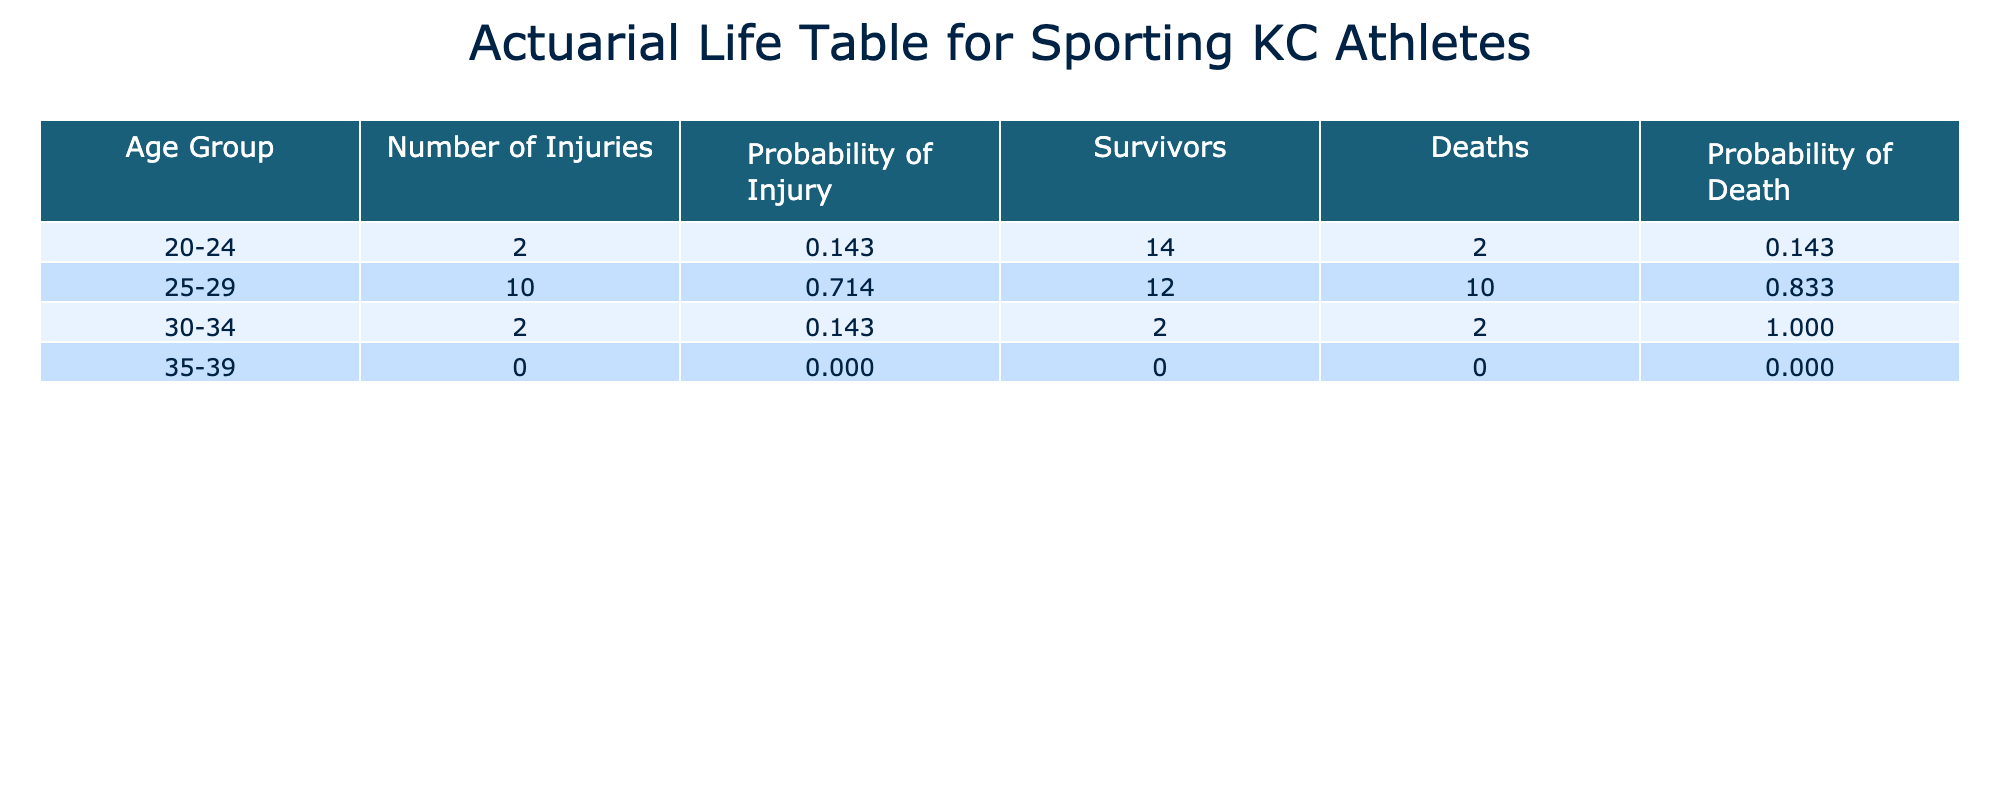What is the age group with the highest number of injuries? Looking at the "Number of Injuries" column, we see the counts for each age group. The age group "25-29" has 4 injuries, which is the highest compared to the others.
Answer: 25-29 How many athletes suffered hamstring tears? By examining the "Injury Type" column and counting the instances of "Hamstring Tear," we find that there is only one instance listed for Graham Zusi.
Answer: 1 What is the average age at injury for athletes in the "Midfielder" position? To find the average, we gather the ages of midfielders: Zusi (29), Espinoza (28), Sanchez (27), Hernandez (23), and Lobato (26). Their sum is 29 + 28 + 27 + 23 + 26 = 133, and dividing by the number of midfielders (5) gives us an average of 133/5 = 26.6.
Answer: 26.6 Is there a player who had a concussive injury? We check the "Injury Type" and find that Felipe Hernandez had a "Concussion." Therefore, the statement is true.
Answer: Yes What is the difference in the time lost due to the longest and shortest injuries? From the "Time Lost" column, the longest time lost is Andreu Fontas with 8 months and the shortest is Daniel Salloi and Felipe Hernandez with 1 month each. The difference is 8 - 1 = 7 months.
Answer: 7 months What percentage of injuries occurred among athletes aged 30-34? For the "30-34" age group, we find 4 injuries (Zusi, Besler, Fontas, and Isimat-Mirin) out of a total of 14 injuries. To find the percentage, we calculate (4/14) * 100 = 28.57%.
Answer: 28.57% Which athlete had the longest recovery time? Referring to the "Time Lost" column, Andreu Fontas had the longest recovery time of 8 months, which concludes that he is the athlete with the longest recovery period.
Answer: Andreu Fontas Did any athlete return to play at the same age as they were injured? Observing the "Return to Play Age" and "Age at Injury," we see that Ilie Sanchez returned to play at age 27, which is the same age he was injured. Hence, the statement is true.
Answer: Yes 